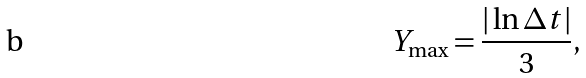<formula> <loc_0><loc_0><loc_500><loc_500>Y _ { \max } = \frac { | \ln \Delta t | } { 3 } ,</formula> 